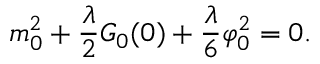<formula> <loc_0><loc_0><loc_500><loc_500>m _ { 0 } ^ { 2 } + \frac { \lambda } { 2 } G _ { 0 } ( 0 ) + \frac { \lambda } { 6 } \varphi _ { 0 } ^ { 2 } = 0 .</formula> 